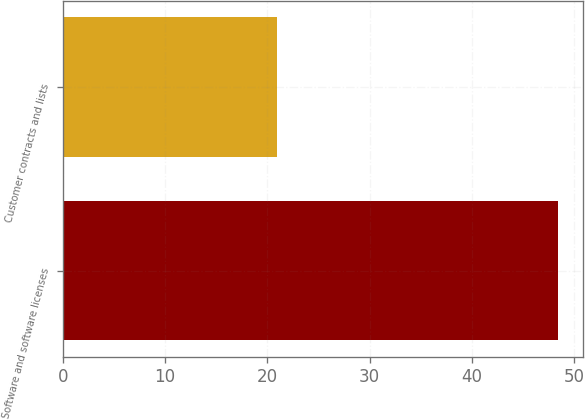<chart> <loc_0><loc_0><loc_500><loc_500><bar_chart><fcel>Software and software licenses<fcel>Customer contracts and lists<nl><fcel>48.4<fcel>20.9<nl></chart> 